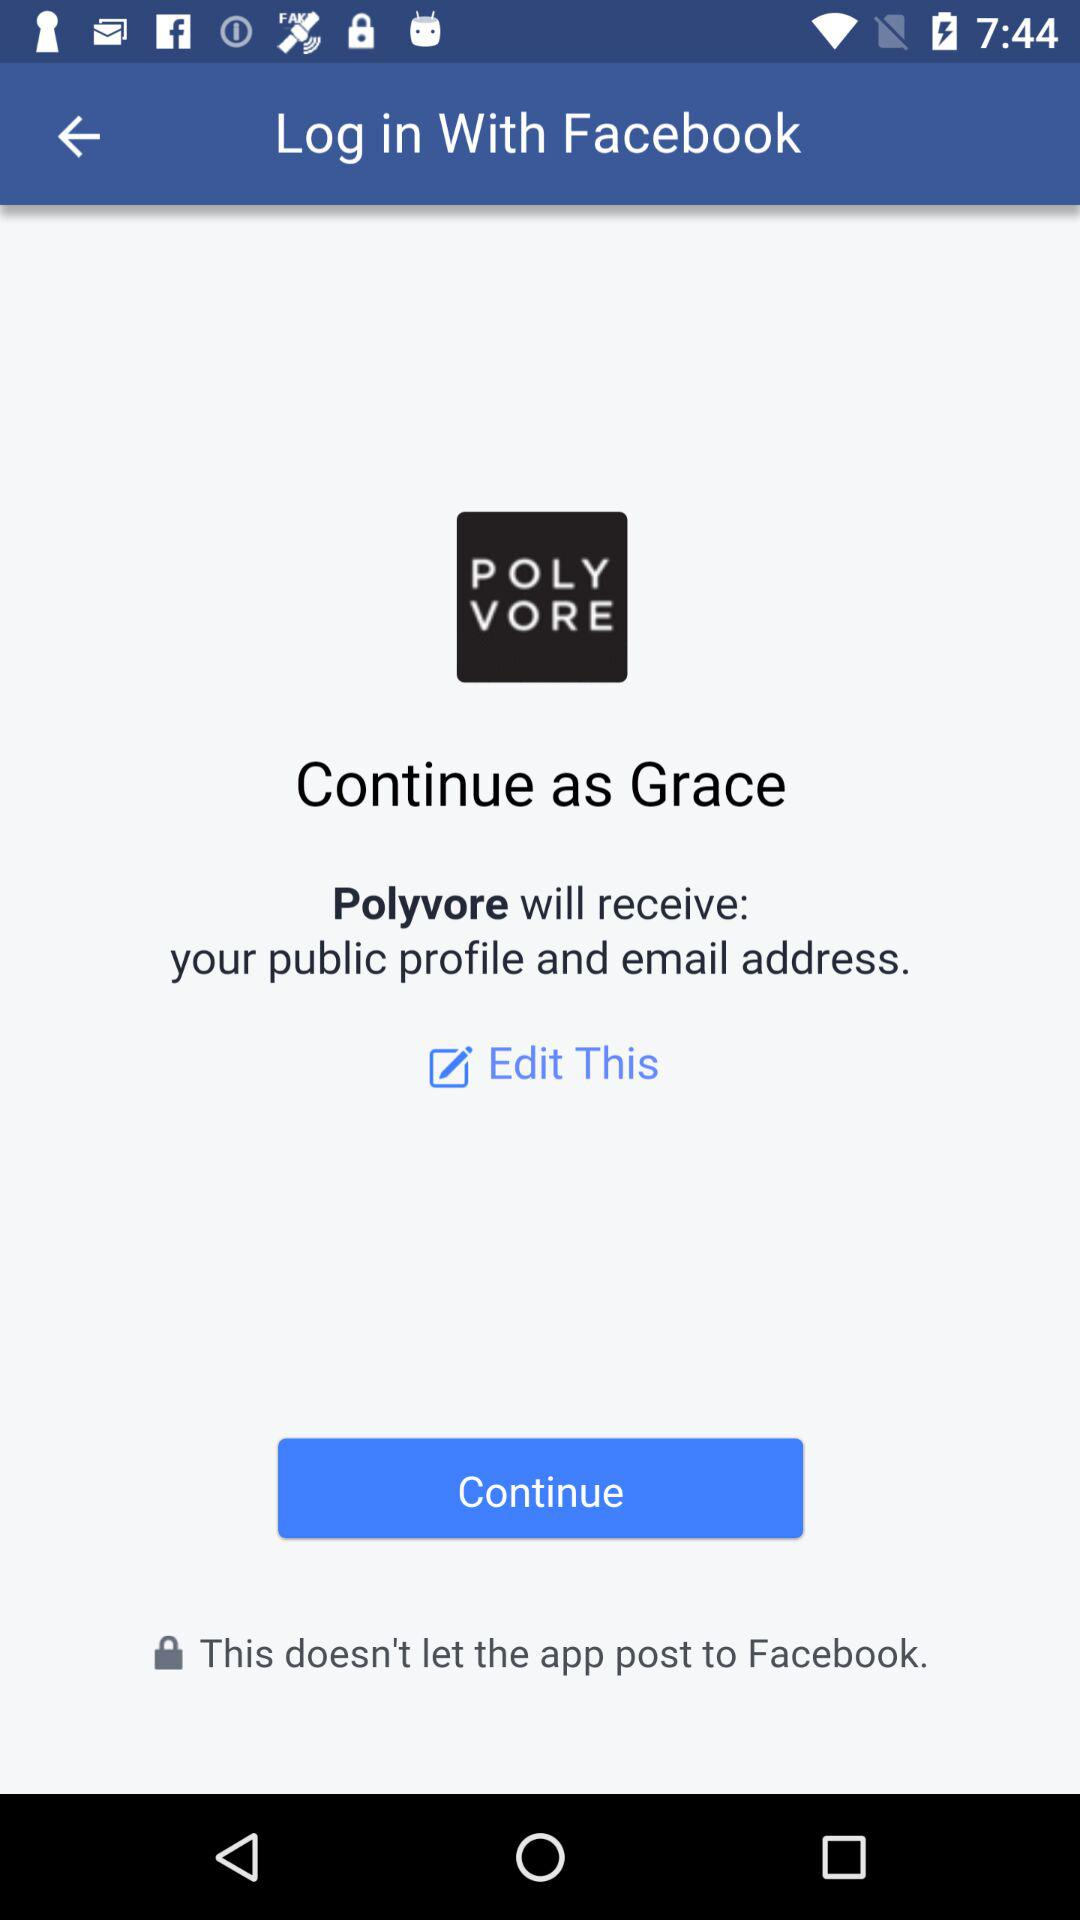Through what application can we log in? You can log in through "Facebook". 